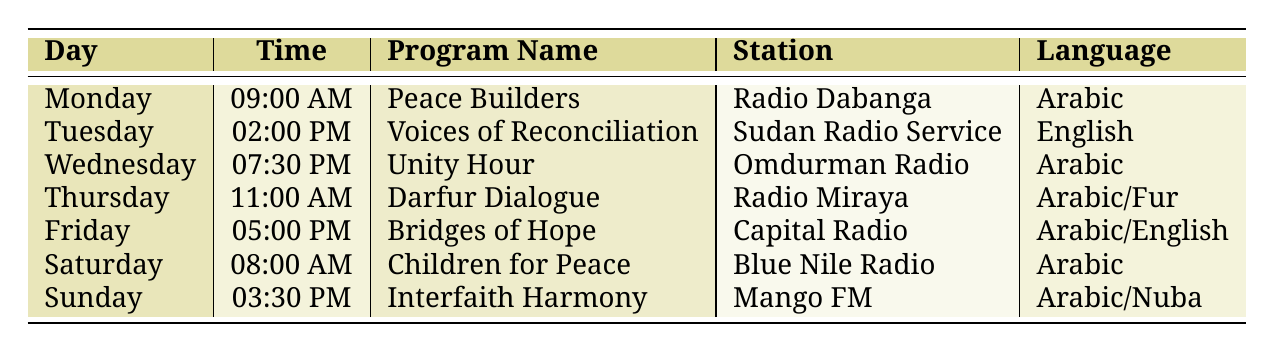What is the program scheduled on Monday? According to the table, the program scheduled on Monday at 09:00 AM is "Peace Builders."
Answer: Peace Builders Which radio station broadcasts "Voices of Reconciliation"? The table indicates that "Voices of Reconciliation," which airs on Tuesday at 02:00 PM, is broadcast on Sudan Radio Service.
Answer: Sudan Radio Service How many programs are broadcast in English? From the table, "Voices of Reconciliation" and "Bridges of Hope" are the only programs listed in English, making a total of 2 programs.
Answer: 2 What time does "Interfaith Harmony" air? The table shows that "Interfaith Harmony" is scheduled for Sunday at 03:30 PM.
Answer: 03:30 PM Is there any program that includes the Fur language? The table lists "Darfur Dialogue," which airs on Thursday as a program that includes the Fur language alongside Arabic.
Answer: Yes What is the difference in air time between "Peace Builders" and "Children for Peace"? "Peace Builders" airs on Monday at 09:00 AM, and "Children for Peace" airs on Saturday at 08:00 AM. The difference in time is 1 hour.
Answer: 1 hour Which day has two languages in its program? The table shows that "Bridges of Hope," airing on Friday, is listed as being broadcast in both Arabic and English, making it the day with two languages.
Answer: Friday What program has the latest time slot? The program with the latest scheduled time is "Unity Hour," which airs on Wednesday at 07:30 PM, making it the latest program in the week.
Answer: Unity Hour Are there any programs that focus on children? "Children for Peace," which airs on Saturday, is the program specifically focused on children.
Answer: Yes 